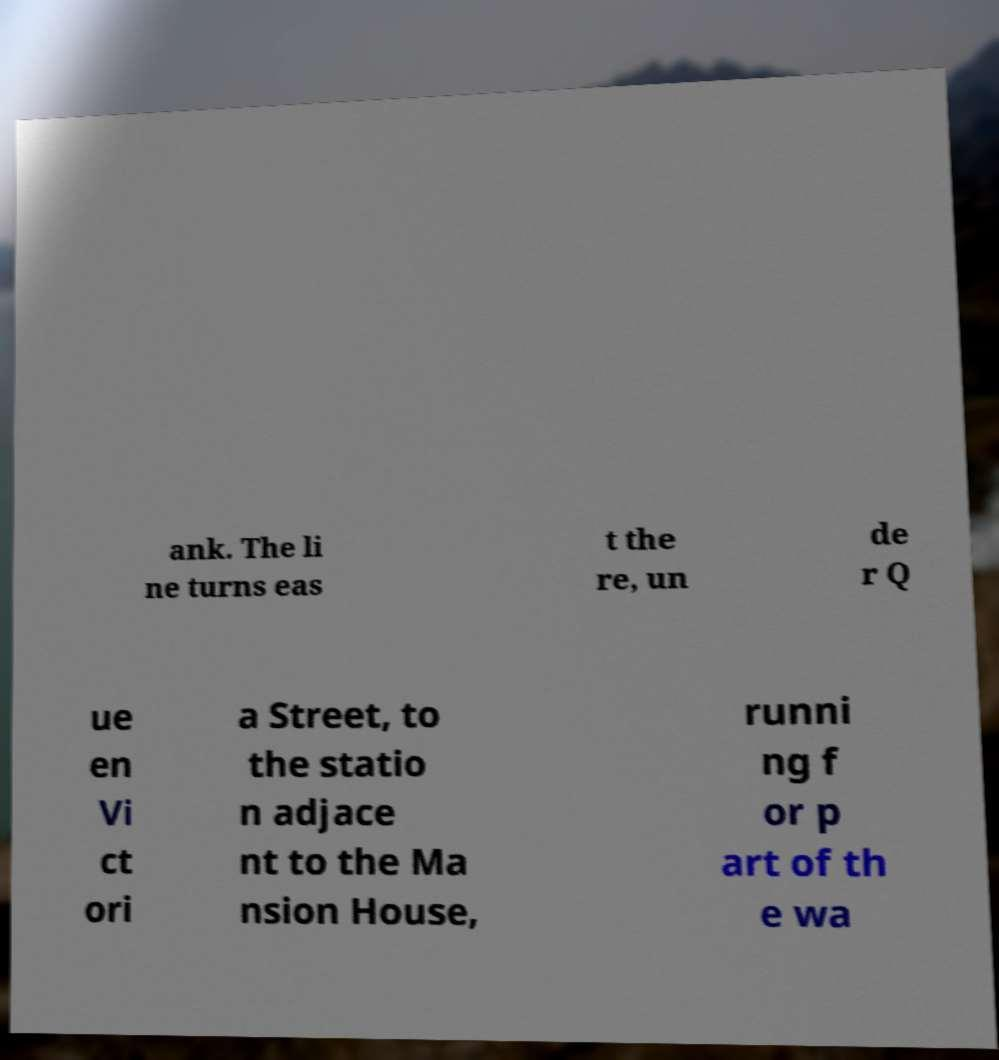I need the written content from this picture converted into text. Can you do that? ank. The li ne turns eas t the re, un de r Q ue en Vi ct ori a Street, to the statio n adjace nt to the Ma nsion House, runni ng f or p art of th e wa 